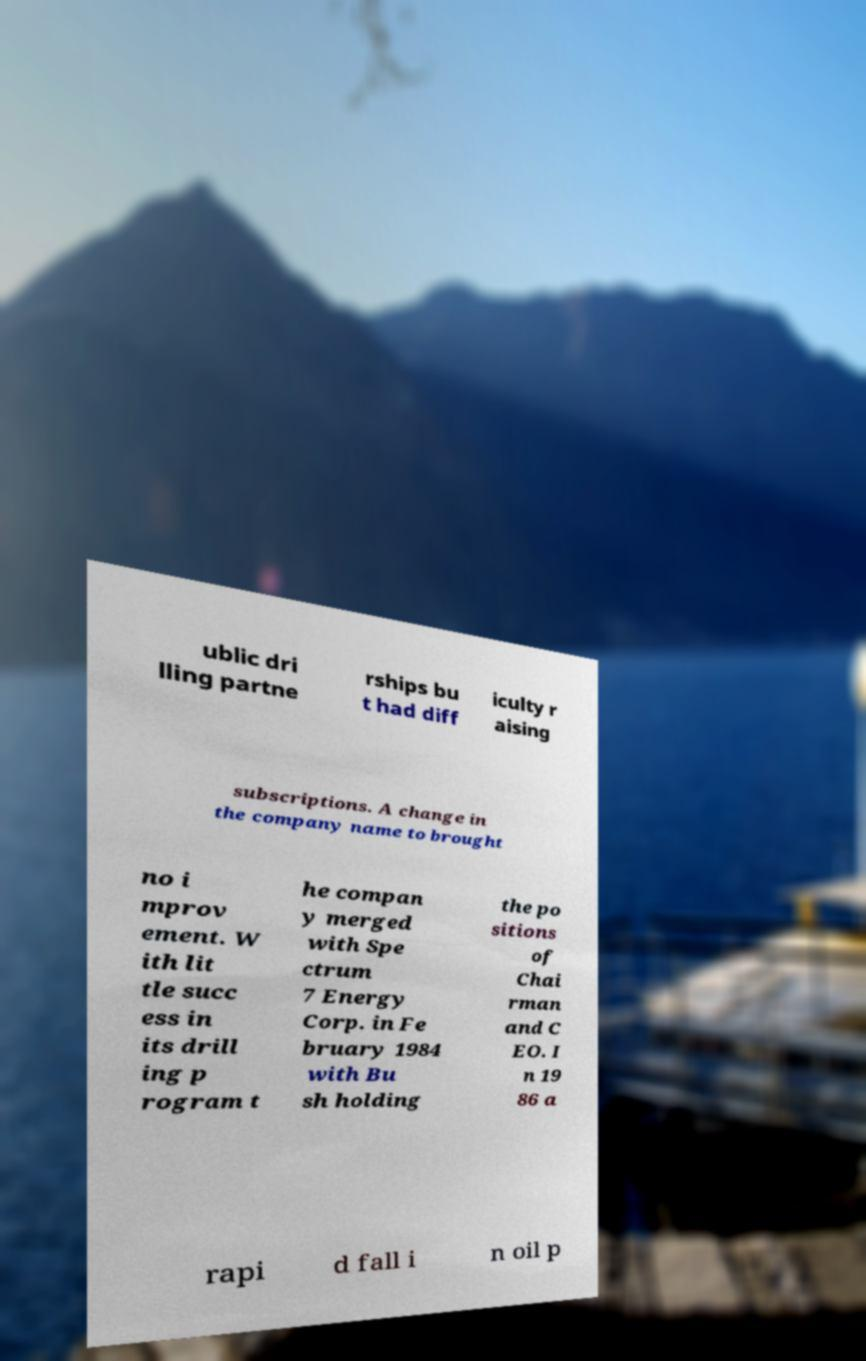Could you assist in decoding the text presented in this image and type it out clearly? ublic dri lling partne rships bu t had diff iculty r aising subscriptions. A change in the company name to brought no i mprov ement. W ith lit tle succ ess in its drill ing p rogram t he compan y merged with Spe ctrum 7 Energy Corp. in Fe bruary 1984 with Bu sh holding the po sitions of Chai rman and C EO. I n 19 86 a rapi d fall i n oil p 